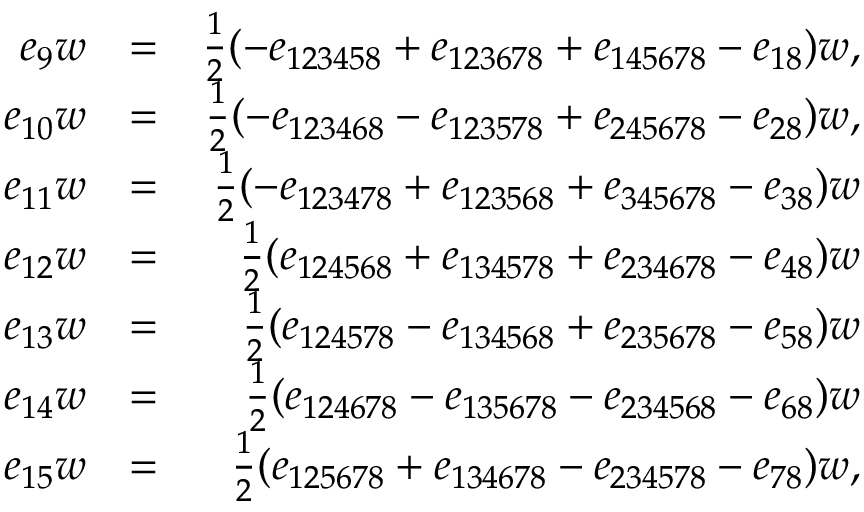Convert formula to latex. <formula><loc_0><loc_0><loc_500><loc_500>\begin{array} { r l r } { e _ { 9 } w } & { = } & { \frac { 1 } { 2 } ( - e _ { 1 2 3 4 5 8 } + e _ { 1 2 3 6 7 8 } + e _ { 1 4 5 6 7 8 } - e _ { 1 8 } ) w , } \\ { e _ { 1 0 } w } & { = } & { \frac { 1 } { 2 } ( - e _ { 1 2 3 4 6 8 } - e _ { 1 2 3 5 7 8 } + e _ { 2 4 5 6 7 8 } - e _ { 2 8 } ) w , } \\ { e _ { 1 1 } w } & { = } & { \frac { 1 } { 2 } ( - e _ { 1 2 3 4 7 8 } + e _ { 1 2 3 5 6 8 } + e _ { 3 4 5 6 7 8 } - e _ { 3 8 } ) w } \\ { e _ { 1 2 } w } & { = } & { \frac { 1 } { 2 } ( e _ { 1 2 4 5 6 8 } + e _ { 1 3 4 5 7 8 } + e _ { 2 3 4 6 7 8 } - e _ { 4 8 } ) w } \\ { e _ { 1 3 } w } & { = } & { \frac { 1 } { 2 } ( e _ { 1 2 4 5 7 8 } - e _ { 1 3 4 5 6 8 } + e _ { 2 3 5 6 7 8 } - e _ { 5 8 } ) w } \\ { e _ { 1 4 } w } & { = } & { \frac { 1 } { 2 } ( e _ { 1 2 4 6 7 8 } - e _ { 1 3 5 6 7 8 } - e _ { 2 3 4 5 6 8 } - e _ { 6 8 } ) w } \\ { e _ { 1 5 } w } & { = } & { \frac { 1 } { 2 } ( e _ { 1 2 5 6 7 8 } + e _ { 1 3 4 6 7 8 } - e _ { 2 3 4 5 7 8 } - e _ { 7 8 } ) w , } \end{array}</formula> 